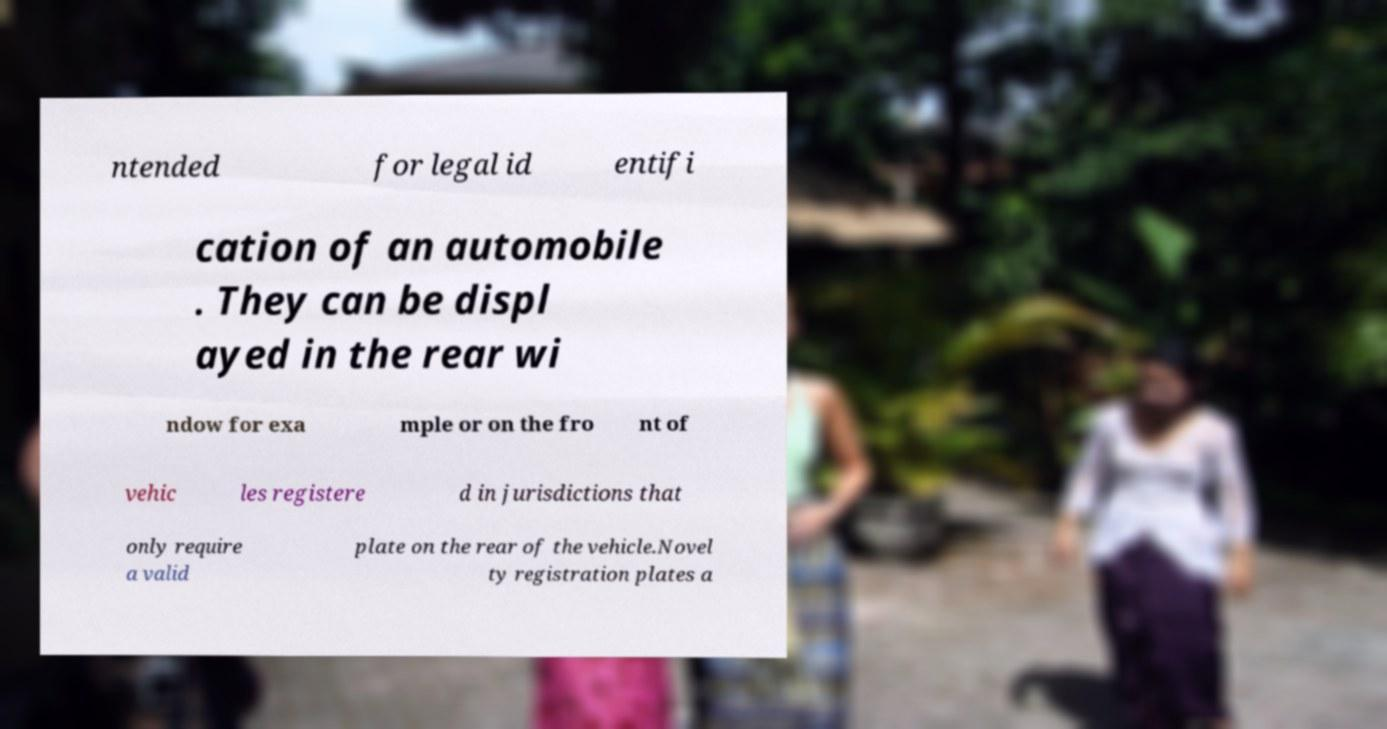Please identify and transcribe the text found in this image. ntended for legal id entifi cation of an automobile . They can be displ ayed in the rear wi ndow for exa mple or on the fro nt of vehic les registere d in jurisdictions that only require a valid plate on the rear of the vehicle.Novel ty registration plates a 